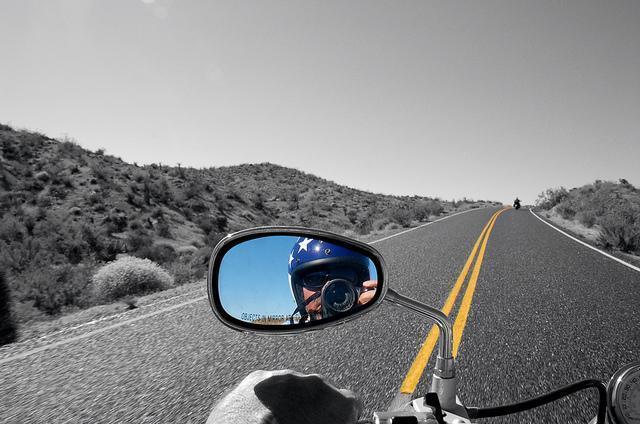How many chairs are there?
Give a very brief answer. 0. 